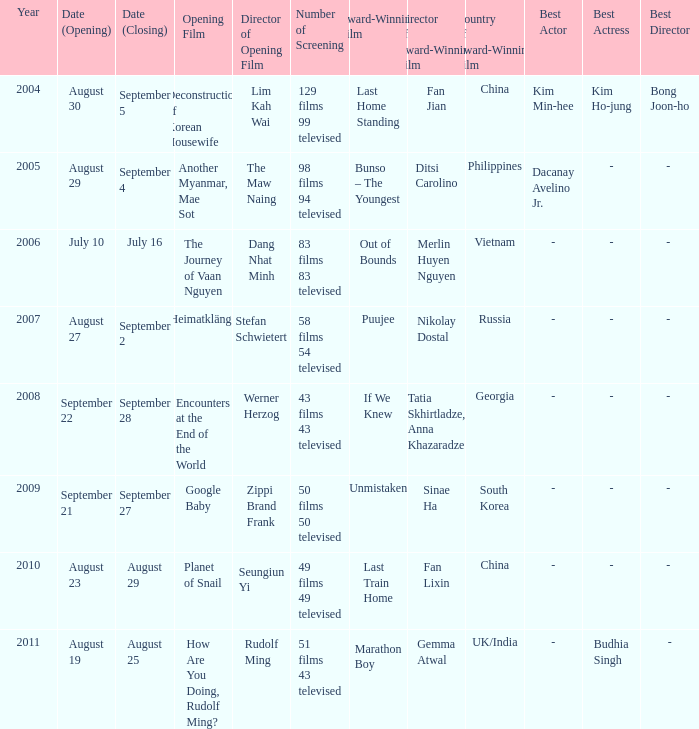What is the total count of screenings for the opening film, the journey of vaan nguyen? 1.0. 